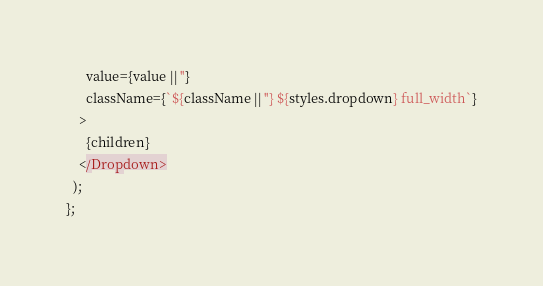<code> <loc_0><loc_0><loc_500><loc_500><_TypeScript_>      value={value || ''}
      className={`${className || ''} ${styles.dropdown} full_width`}
    >
      {children}
    </Dropdown>
  );
};
</code> 